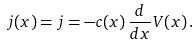<formula> <loc_0><loc_0><loc_500><loc_500>j ( x ) = j = - c ( x ) \, \frac { d } { d x } V ( x ) \, .</formula> 